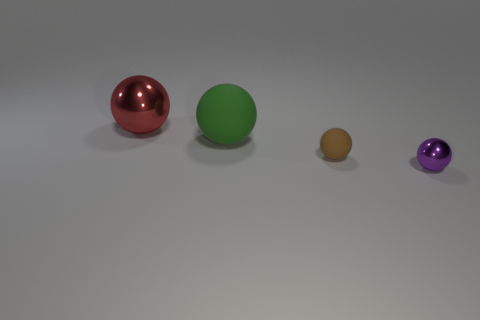Subtract 1 spheres. How many spheres are left? 3 Subtract all red balls. How many balls are left? 3 Subtract all big red spheres. How many spheres are left? 3 Subtract all yellow balls. Subtract all green blocks. How many balls are left? 4 Add 4 green matte spheres. How many objects exist? 8 Subtract all large cyan blocks. Subtract all green matte balls. How many objects are left? 3 Add 1 tiny brown objects. How many tiny brown objects are left? 2 Add 4 tiny purple spheres. How many tiny purple spheres exist? 5 Subtract 0 gray cylinders. How many objects are left? 4 